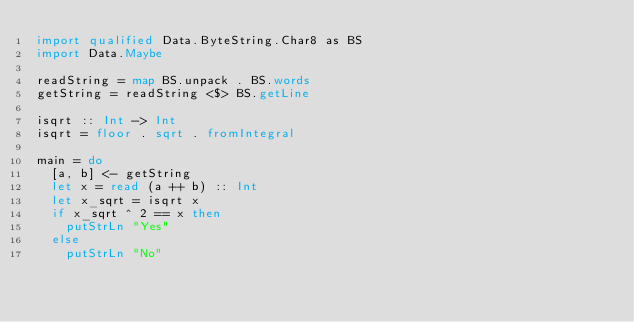Convert code to text. <code><loc_0><loc_0><loc_500><loc_500><_Haskell_>import qualified Data.ByteString.Char8 as BS
import Data.Maybe

readString = map BS.unpack . BS.words
getString = readString <$> BS.getLine

isqrt :: Int -> Int
isqrt = floor . sqrt . fromIntegral

main = do
  [a, b] <- getString
  let x = read (a ++ b) :: Int
  let x_sqrt = isqrt x
  if x_sqrt ^ 2 == x then
    putStrLn "Yes"
  else
    putStrLn "No"</code> 